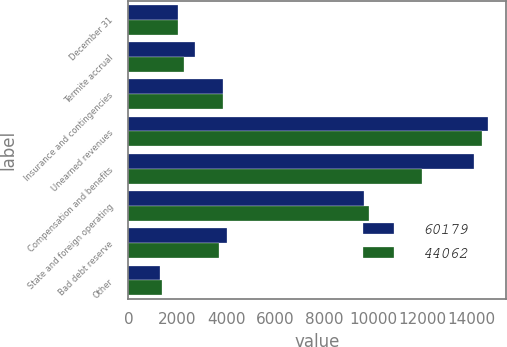<chart> <loc_0><loc_0><loc_500><loc_500><stacked_bar_chart><ecel><fcel>December 31<fcel>Termite accrual<fcel>Insurance and contingencies<fcel>Unearned revenues<fcel>Compensation and benefits<fcel>State and foreign operating<fcel>Bad debt reserve<fcel>Other<nl><fcel>60179<fcel>2013<fcel>2738<fcel>3867.5<fcel>14692<fcel>14100<fcel>9637<fcel>4032<fcel>1275<nl><fcel>44062<fcel>2012<fcel>2288<fcel>3867.5<fcel>14413<fcel>11984<fcel>9838<fcel>3703<fcel>1384<nl></chart> 